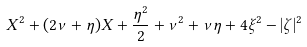<formula> <loc_0><loc_0><loc_500><loc_500>X ^ { 2 } + ( 2 \nu + \eta ) X + \frac { \eta ^ { 2 } } { 2 } + \nu ^ { 2 } + \nu \eta + 4 \xi ^ { 2 } - | \zeta | ^ { 2 }</formula> 